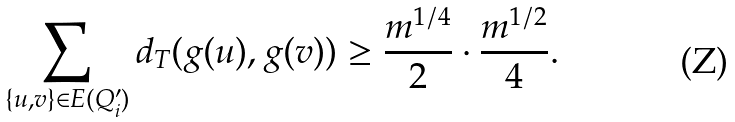Convert formula to latex. <formula><loc_0><loc_0><loc_500><loc_500>\sum _ { \{ u , v \} \in E ( Q _ { i } ^ { \prime } ) } d _ { T } ( g ( u ) , g ( v ) ) \geq \frac { m ^ { 1 / 4 } } { 2 } \cdot \frac { m ^ { 1 / 2 } } { 4 } .</formula> 